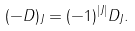Convert formula to latex. <formula><loc_0><loc_0><loc_500><loc_500>( - D ) _ { J } = ( - 1 ) ^ { | J | } D _ { J } .</formula> 